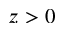Convert formula to latex. <formula><loc_0><loc_0><loc_500><loc_500>z > 0</formula> 